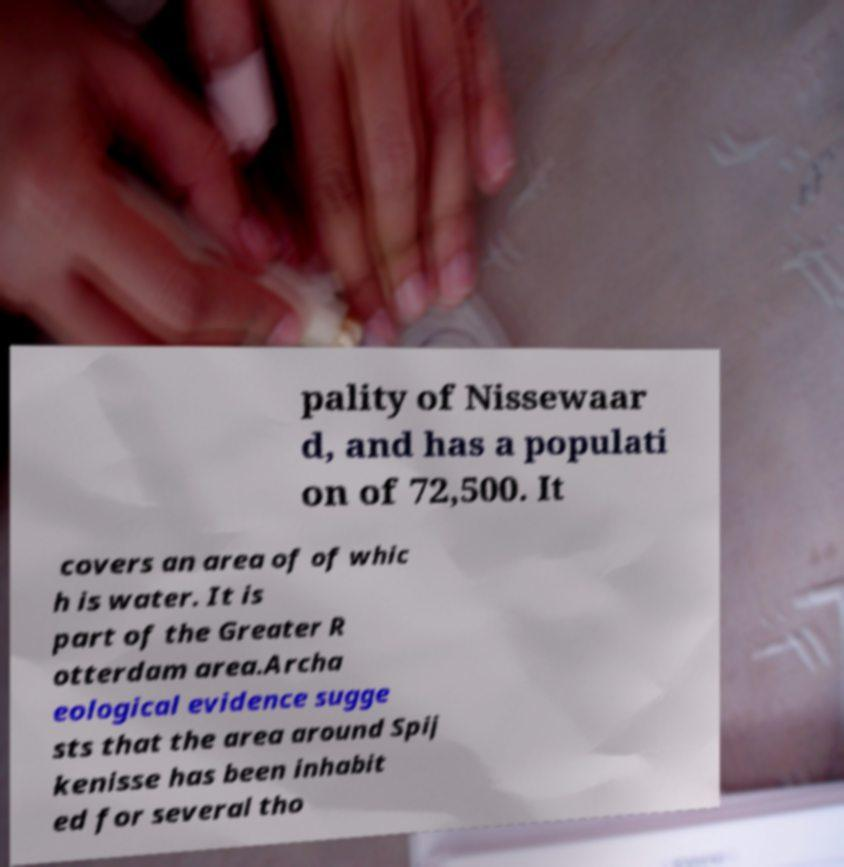For documentation purposes, I need the text within this image transcribed. Could you provide that? pality of Nissewaar d, and has a populati on of 72,500. It covers an area of of whic h is water. It is part of the Greater R otterdam area.Archa eological evidence sugge sts that the area around Spij kenisse has been inhabit ed for several tho 